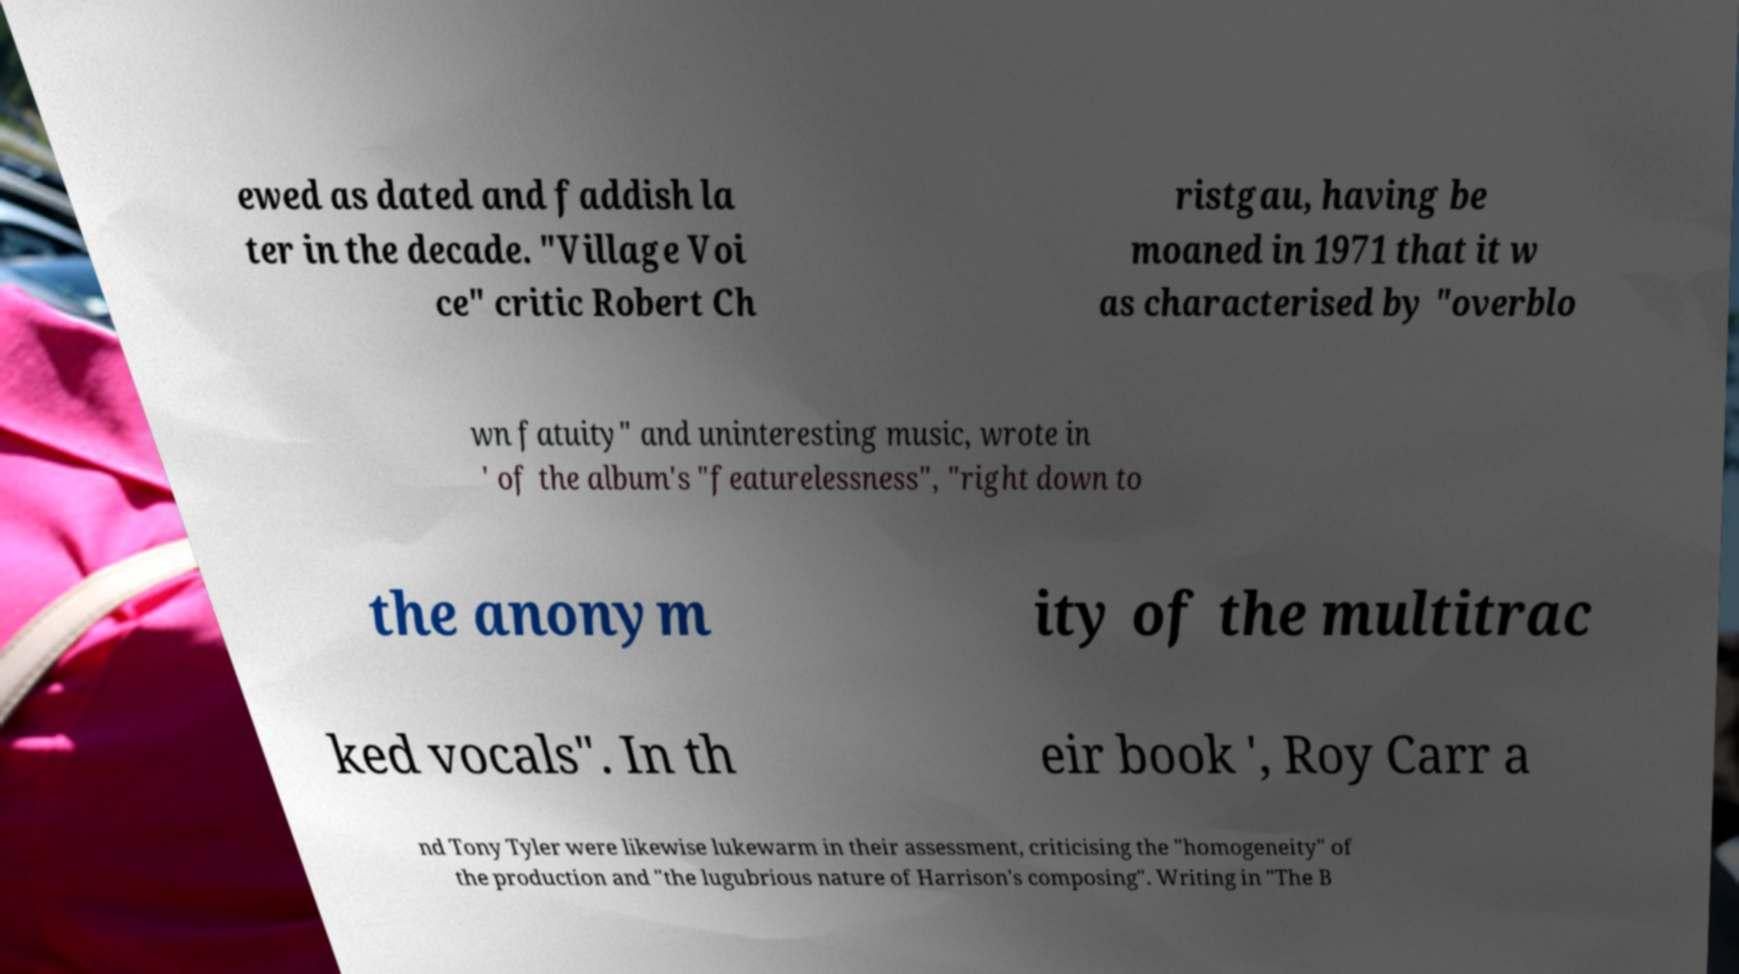Please read and relay the text visible in this image. What does it say? ewed as dated and faddish la ter in the decade. "Village Voi ce" critic Robert Ch ristgau, having be moaned in 1971 that it w as characterised by "overblo wn fatuity" and uninteresting music, wrote in ' of the album's "featurelessness", "right down to the anonym ity of the multitrac ked vocals". In th eir book ', Roy Carr a nd Tony Tyler were likewise lukewarm in their assessment, criticising the "homogeneity" of the production and "the lugubrious nature of Harrison's composing". Writing in "The B 